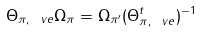Convert formula to latex. <formula><loc_0><loc_0><loc_500><loc_500>\Theta _ { \pi , \ v e } \Omega _ { \pi } = \Omega _ { \pi ^ { \prime } } ( \Theta _ { \pi , \ v e } ^ { t } ) ^ { - 1 }</formula> 